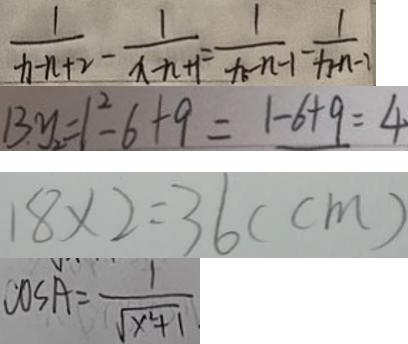<formula> <loc_0><loc_0><loc_500><loc_500>\frac { 1 } { x - n + 2 } - \frac { 1 } { x - n + 1 } = \frac { 1 } { x - n - 1 } - \frac { 1 } { x - n - 1 } 
 1 3 y _ { 2 } = 1 ^ { 2 } - 6 + 9 = 1 - 6 + 9 = 4 
 1 8 \times 2 = 3 6 ( c m ) 
 C 0 s A = \frac { 1 } { \sqrt { x ^ { 2 } + 1 } }</formula> 